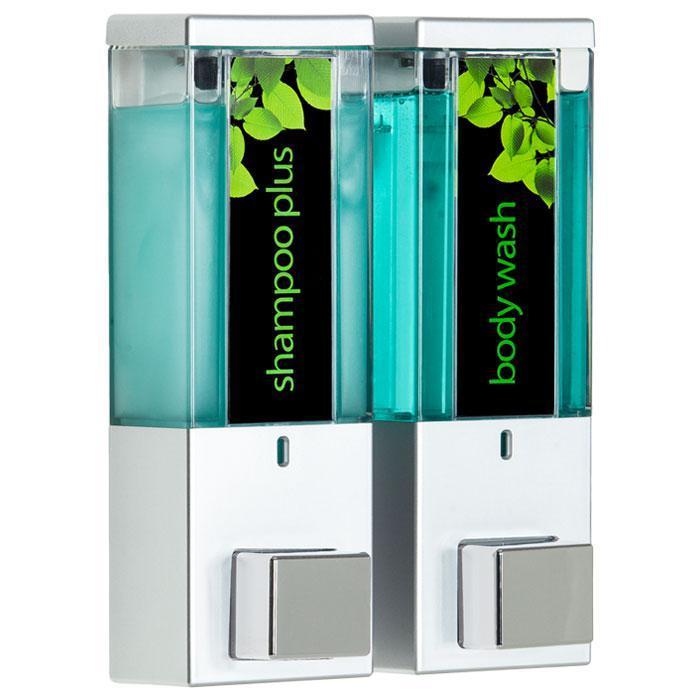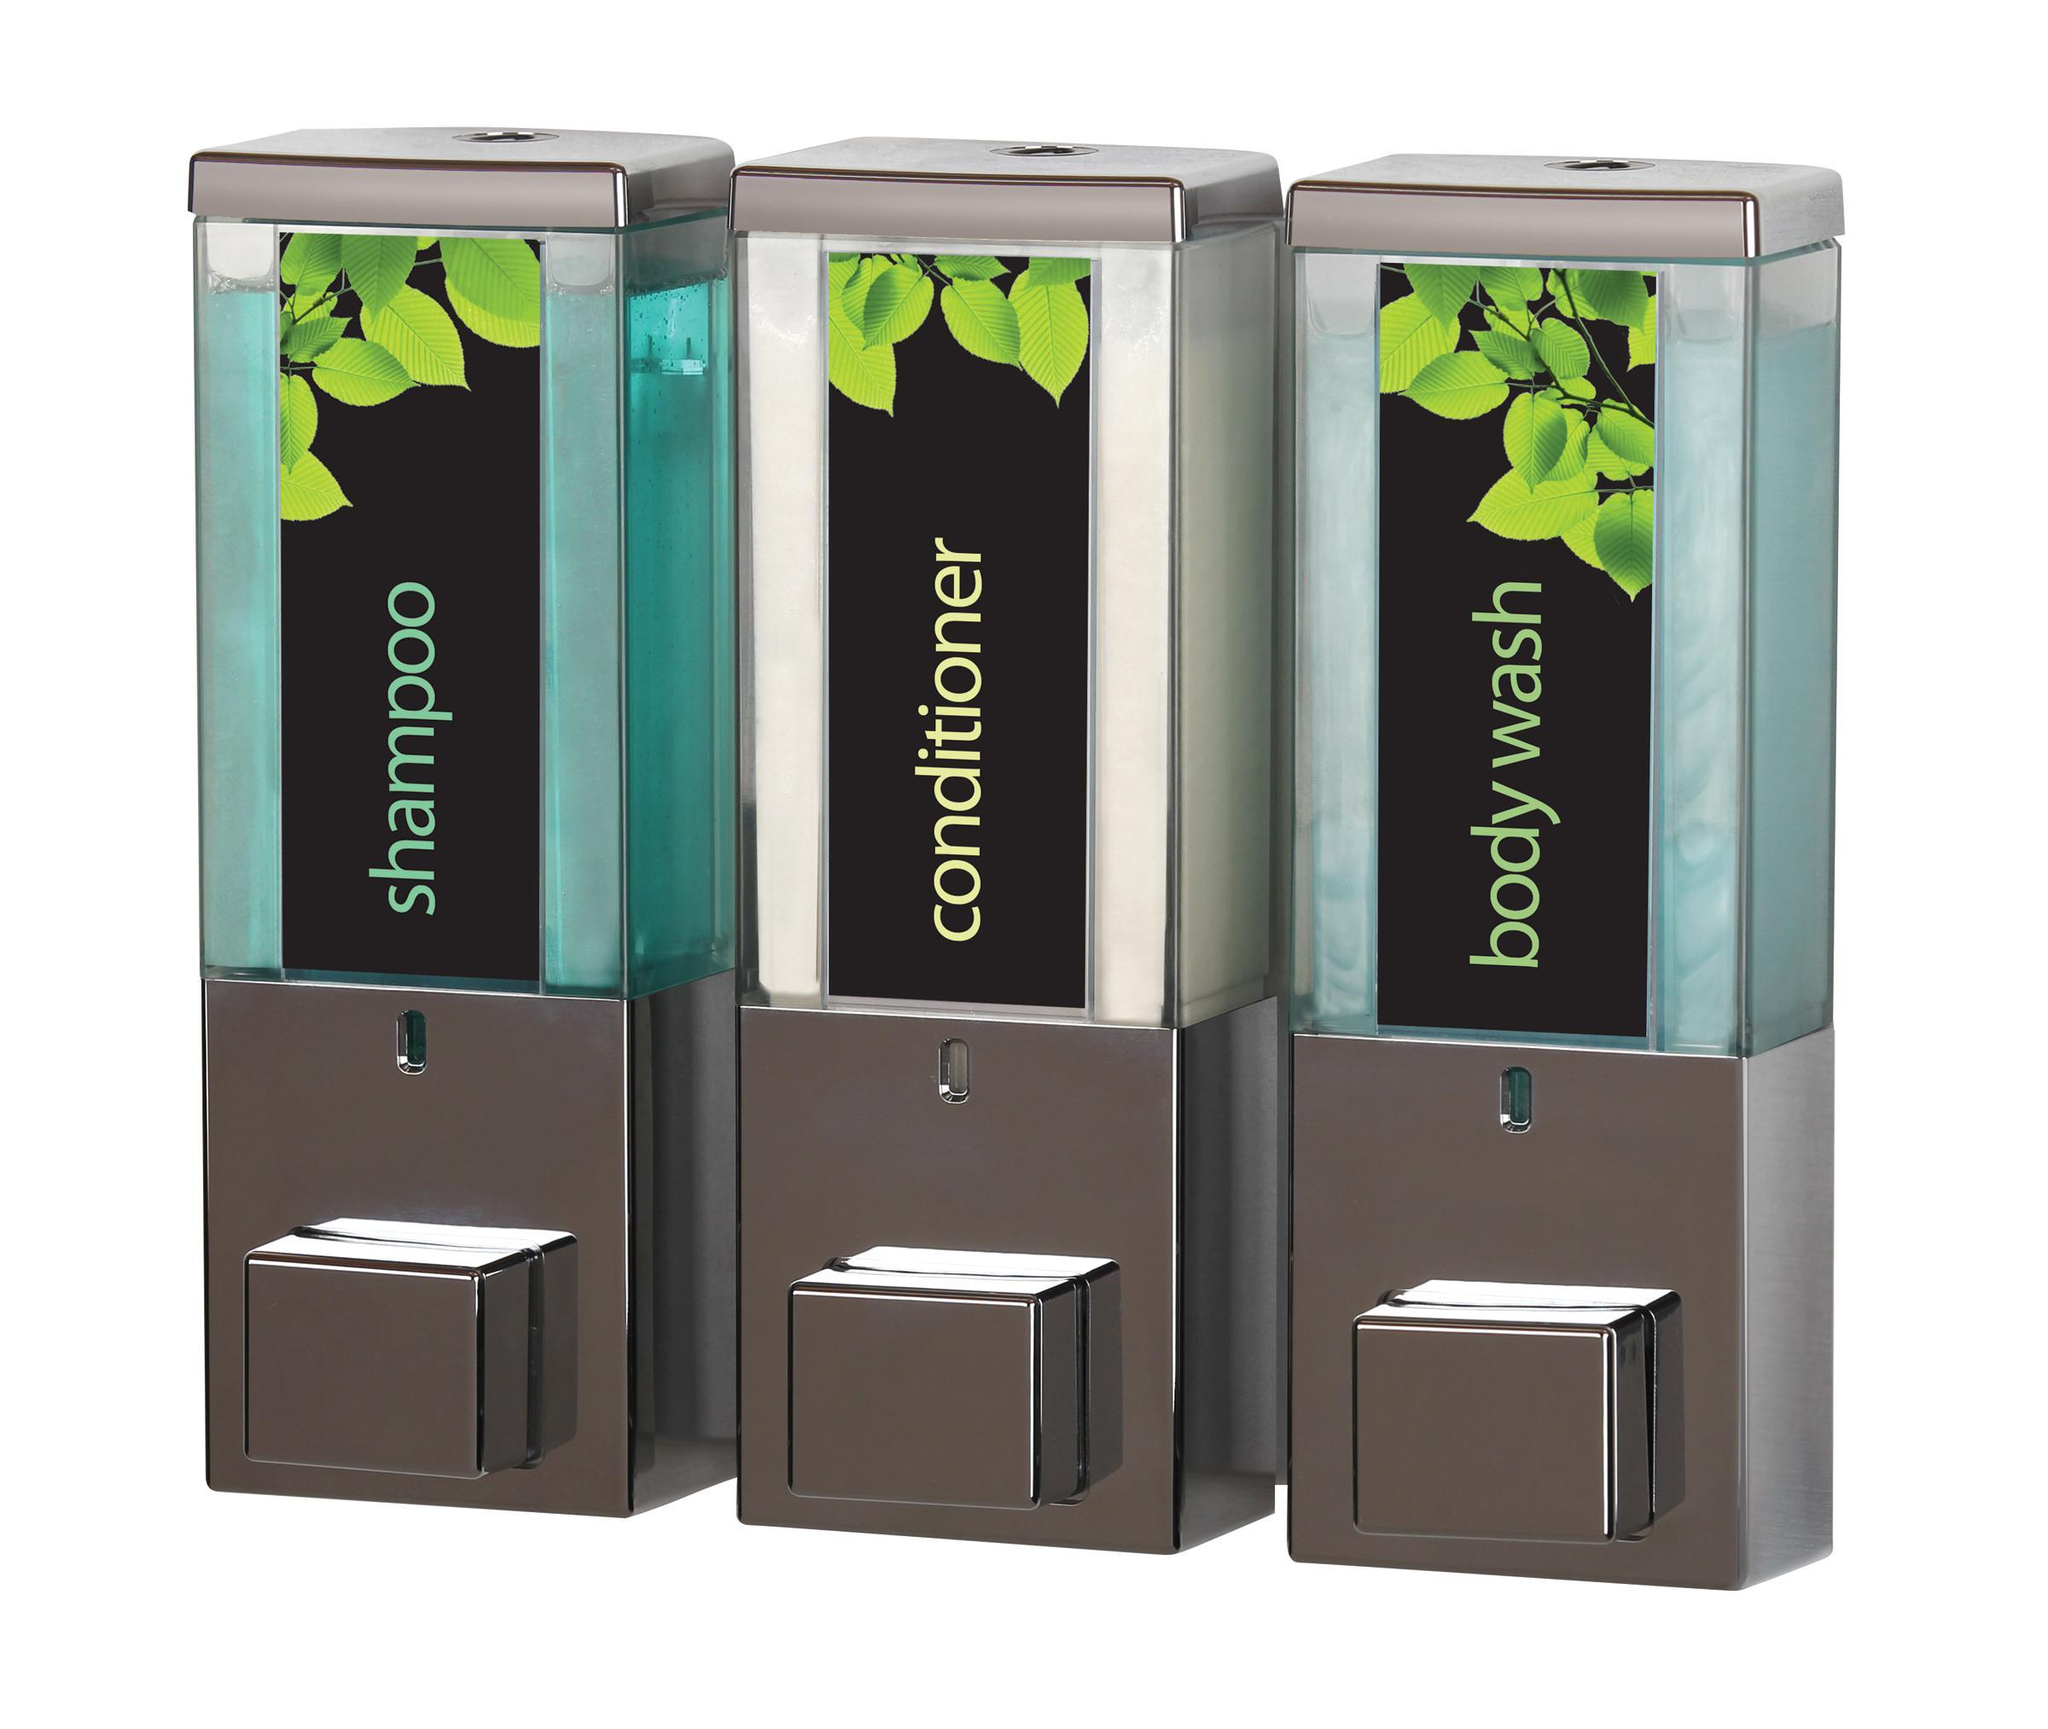The first image is the image on the left, the second image is the image on the right. Given the left and right images, does the statement "There are more dispensers in the right image than in the left image." hold true? Answer yes or no. Yes. The first image is the image on the left, the second image is the image on the right. Assess this claim about the two images: "The left image contains both a shampoo container and a body wash container.". Correct or not? Answer yes or no. Yes. 